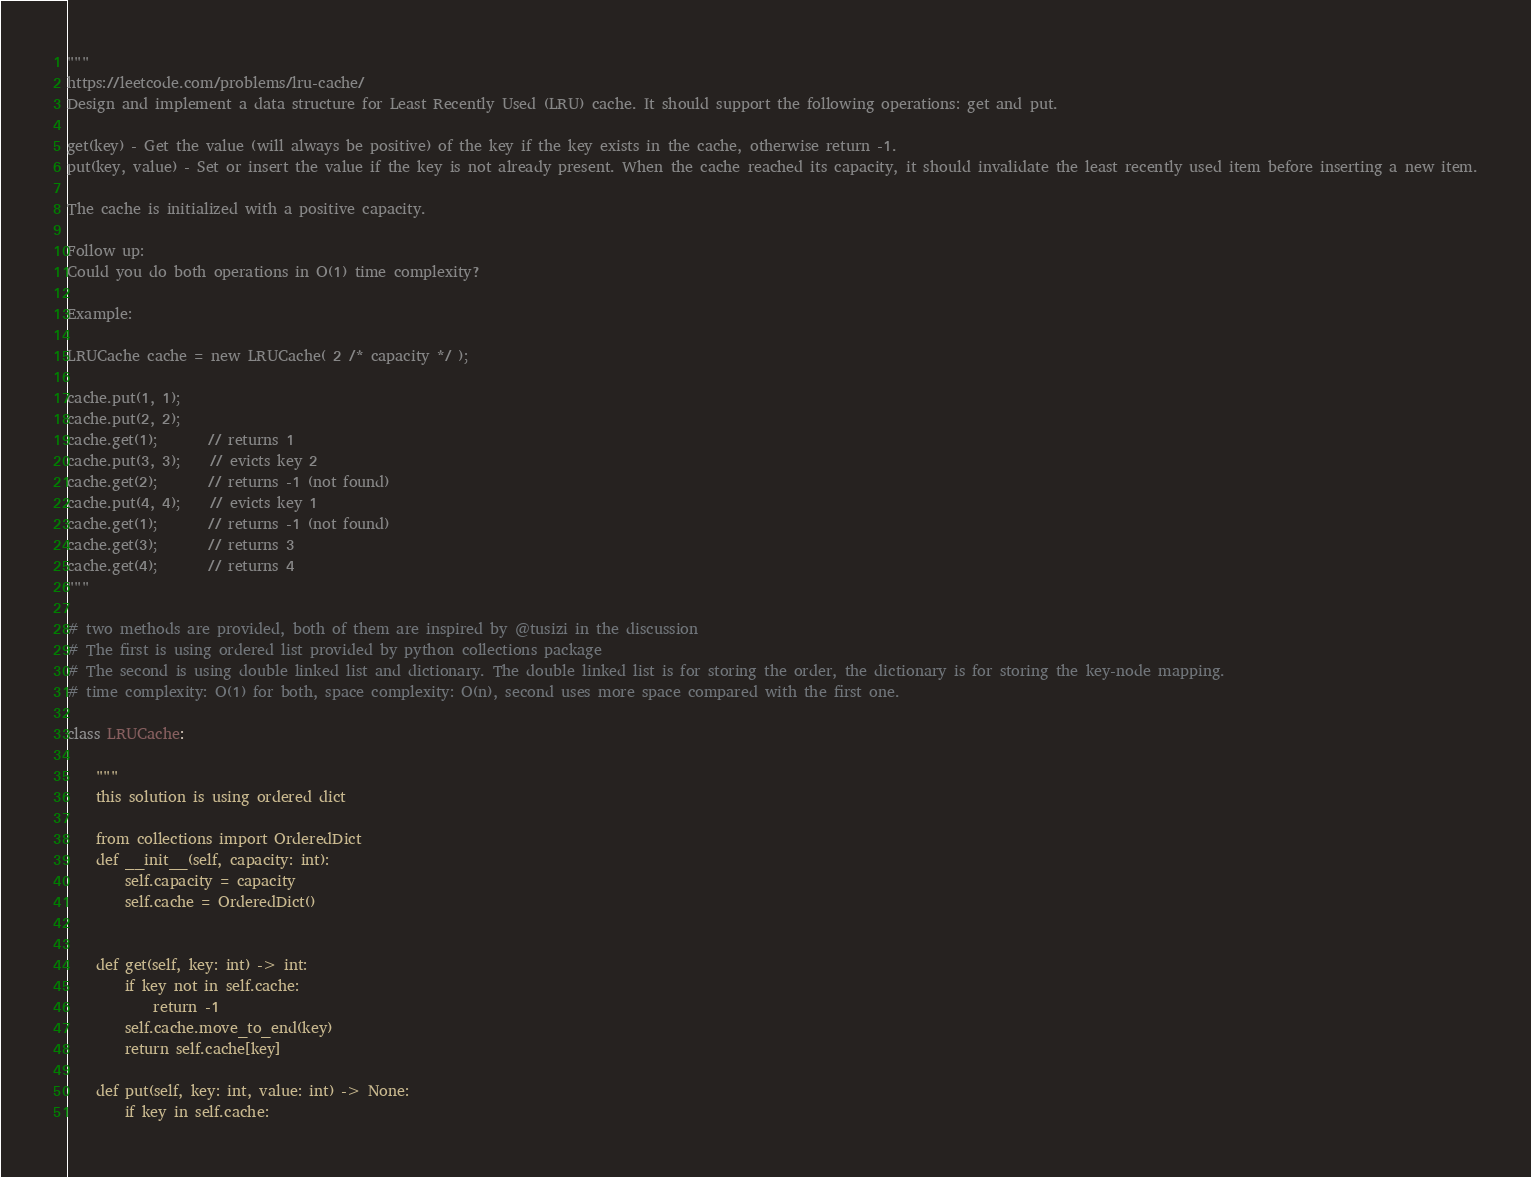Convert code to text. <code><loc_0><loc_0><loc_500><loc_500><_Python_>"""
https://leetcode.com/problems/lru-cache/
Design and implement a data structure for Least Recently Used (LRU) cache. It should support the following operations: get and put.

get(key) - Get the value (will always be positive) of the key if the key exists in the cache, otherwise return -1.
put(key, value) - Set or insert the value if the key is not already present. When the cache reached its capacity, it should invalidate the least recently used item before inserting a new item.

The cache is initialized with a positive capacity.

Follow up:
Could you do both operations in O(1) time complexity?

Example:

LRUCache cache = new LRUCache( 2 /* capacity */ );

cache.put(1, 1);
cache.put(2, 2);
cache.get(1);       // returns 1
cache.put(3, 3);    // evicts key 2
cache.get(2);       // returns -1 (not found)
cache.put(4, 4);    // evicts key 1
cache.get(1);       // returns -1 (not found)
cache.get(3);       // returns 3
cache.get(4);       // returns 4
"""

# two methods are provided, both of them are inspired by @tusizi in the discussion
# The first is using ordered list provided by python collections package
# The second is using double linked list and dictionary. The double linked list is for storing the order, the dictionary is for storing the key-node mapping.
# time complexity: O(1) for both, space complexity: O(n), second uses more space compared with the first one.

class LRUCache:
    
    """
    this solution is using ordered dict
    
    from collections import OrderedDict
    def __init__(self, capacity: int):
        self.capacity = capacity
        self.cache = OrderedDict()
        

    def get(self, key: int) -> int:
        if key not in self.cache:
            return -1
        self.cache.move_to_end(key)
        return self.cache[key]

    def put(self, key: int, value: int) -> None:
        if key in self.cache:</code> 